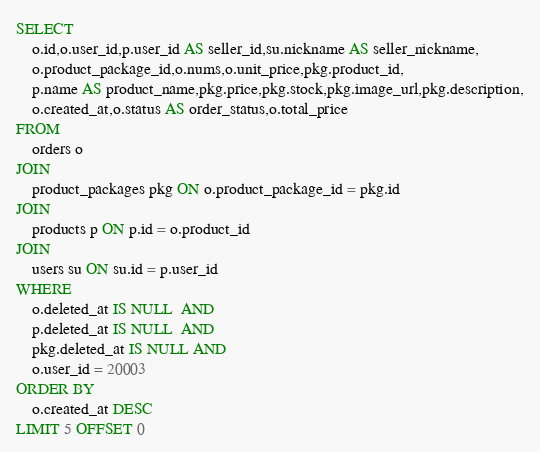<code> <loc_0><loc_0><loc_500><loc_500><_SQL_>SELECT
	o.id,o.user_id,p.user_id AS seller_id,su.nickname AS seller_nickname,
	o.product_package_id,o.nums,o.unit_price,pkg.product_id,
	p.name AS product_name,pkg.price,pkg.stock,pkg.image_url,pkg.description,
	o.created_at,o.status AS order_status,o.total_price
FROM
	orders o
JOIN
	product_packages pkg ON o.product_package_id = pkg.id
JOIN
	products p ON p.id = o.product_id
JOIN 
	users su ON su.id = p.user_id	
WHERE
	o.deleted_at IS NULL  AND
	p.deleted_at IS NULL  AND
	pkg.deleted_at IS NULL AND
	o.user_id = 20003
ORDER BY
	o.created_at DESC
LIMIT 5 OFFSET 0</code> 